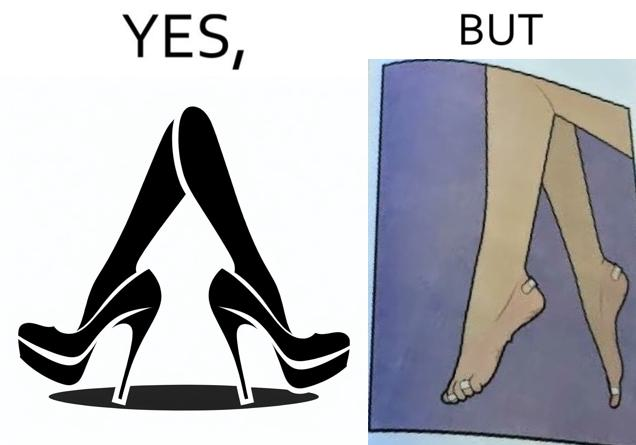Is there satirical content in this image? Yes, this image is satirical. 